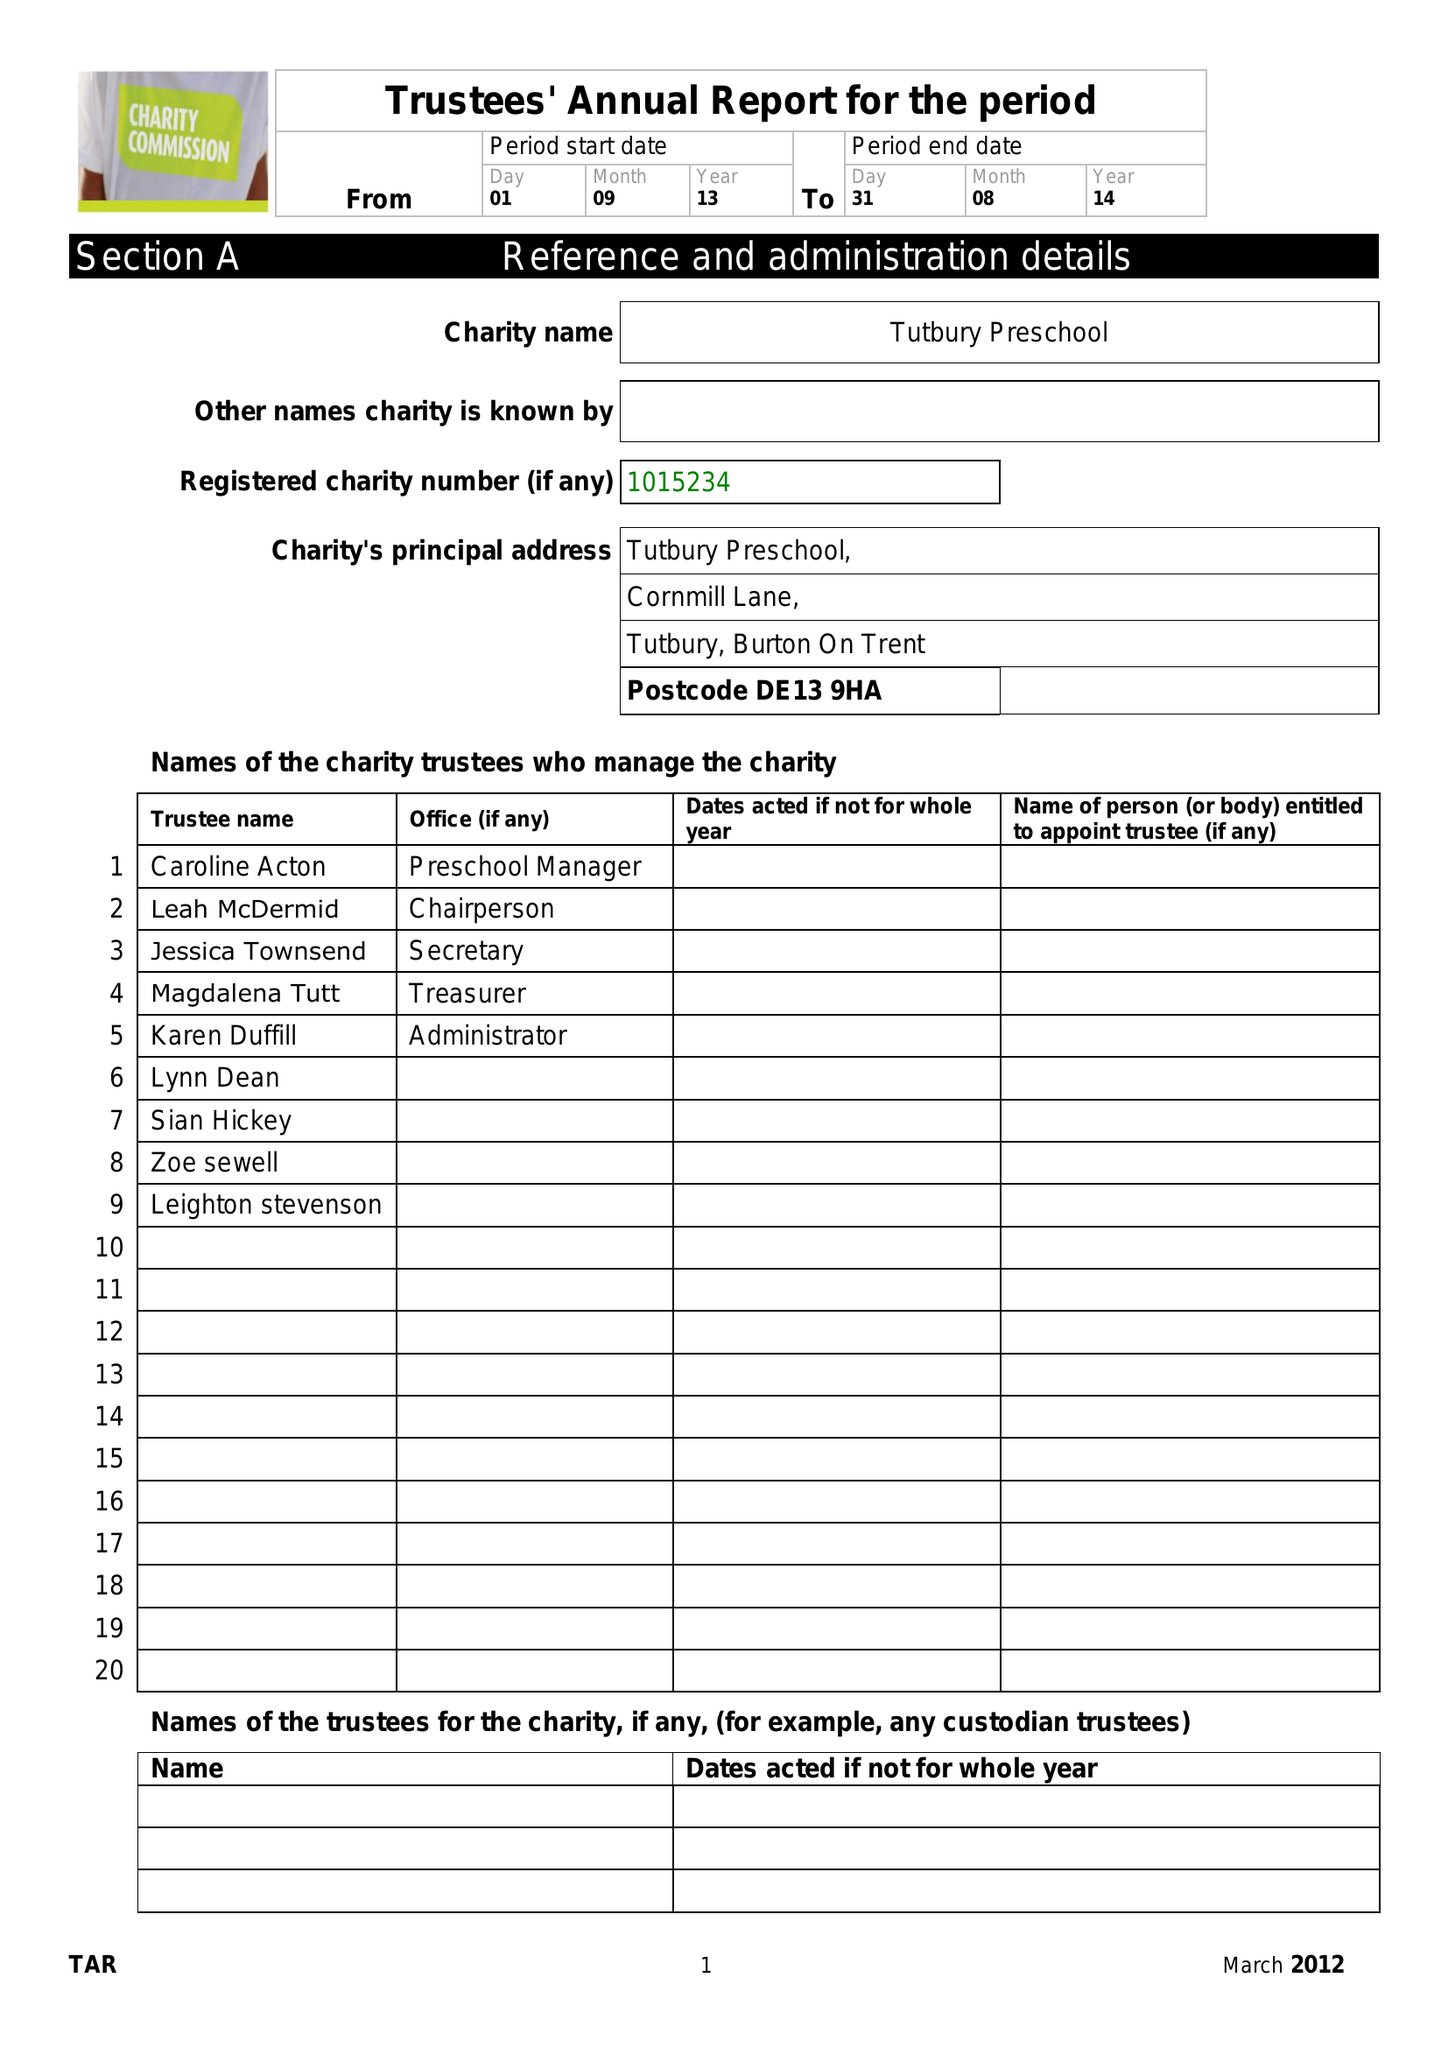What is the value for the income_annually_in_british_pounds?
Answer the question using a single word or phrase. 67578.07 